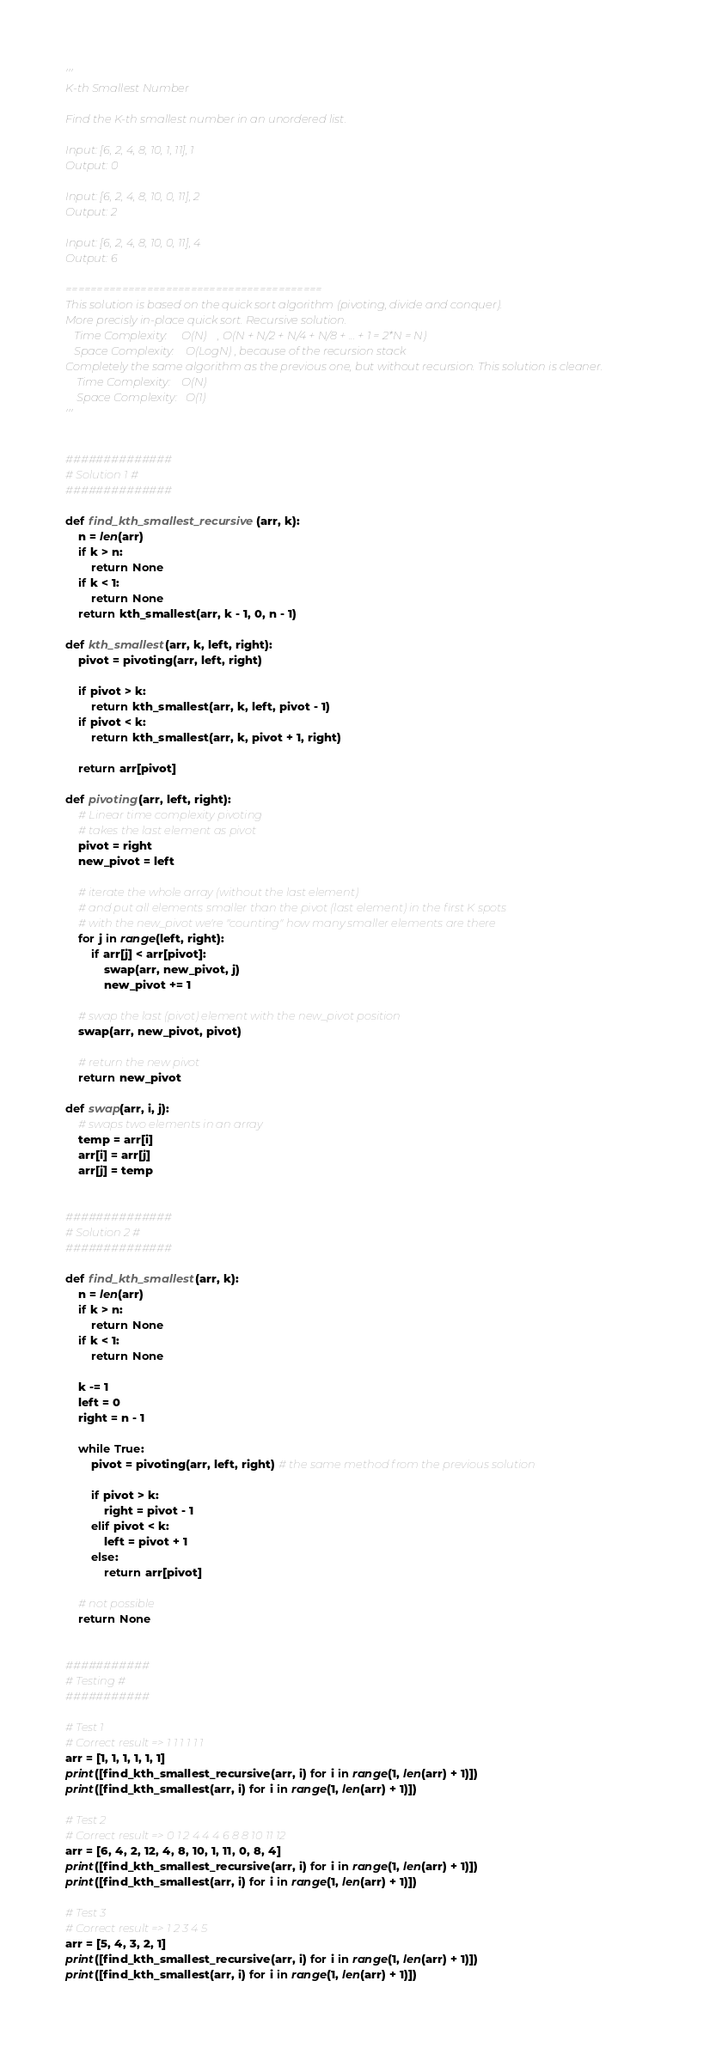Convert code to text. <code><loc_0><loc_0><loc_500><loc_500><_Python_>'''
K-th Smallest Number

Find the K-th smallest number in an unordered list.

Input: [6, 2, 4, 8, 10, 1, 11], 1
Output: 0

Input: [6, 2, 4, 8, 10, 0, 11], 2
Output: 2

Input: [6, 2, 4, 8, 10, 0, 11], 4
Output: 6

=========================================
This solution is based on the quick sort algorithm (pivoting, divide and conquer).
More precisly in-place quick sort. Recursive solution.
   Time Complexity:     O(N)    , O(N + N/2 + N/4 + N/8 + ... + 1 = 2*N = N)
   Space Complexity:    O(LogN) , because of the recursion stack
Completely the same algorithm as the previous one, but without recursion. This solution is cleaner.
    Time Complexity:    O(N)
    Space Complexity:   O(1)
'''


##############
# Solution 1 #
##############

def find_kth_smallest_recursive(arr, k):
    n = len(arr)
    if k > n:
        return None
    if k < 1:
        return None
    return kth_smallest(arr, k - 1, 0, n - 1)

def kth_smallest(arr, k, left, right):
    pivot = pivoting(arr, left, right)

    if pivot > k:
        return kth_smallest(arr, k, left, pivot - 1)
    if pivot < k:
        return kth_smallest(arr, k, pivot + 1, right)

    return arr[pivot]

def pivoting(arr, left, right):
    # Linear time complexity pivoting
    # takes the last element as pivot
    pivot = right
    new_pivot = left

    # iterate the whole array (without the last element)
    # and put all elements smaller than the pivot (last element) in the first K spots
    # with the new_pivot we're "counting" how many smaller elements are there
    for j in range(left, right):
        if arr[j] < arr[pivot]:
            swap(arr, new_pivot, j)
            new_pivot += 1

    # swap the last (pivot) element with the new_pivot position
    swap(arr, new_pivot, pivot)

    # return the new pivot
    return new_pivot

def swap(arr, i, j):
    # swaps two elements in an array
    temp = arr[i]
    arr[i] = arr[j]
    arr[j] = temp


##############
# Solution 2 #
##############

def find_kth_smallest(arr, k):
    n = len(arr)
    if k > n:
        return None
    if k < 1:
        return None

    k -= 1
    left = 0
    right = n - 1

    while True:
        pivot = pivoting(arr, left, right) # the same method from the previous solution

        if pivot > k:
            right = pivot - 1
        elif pivot < k:
            left = pivot + 1
        else:
            return arr[pivot]

    # not possible
    return None


###########
# Testing #
###########

# Test 1
# Correct result => 1 1 1 1 1 1
arr = [1, 1, 1, 1, 1, 1]
print([find_kth_smallest_recursive(arr, i) for i in range(1, len(arr) + 1)])
print([find_kth_smallest(arr, i) for i in range(1, len(arr) + 1)])

# Test 2
# Correct result => 0 1 2 4 4 4 6 8 8 10 11 12
arr = [6, 4, 2, 12, 4, 8, 10, 1, 11, 0, 8, 4]
print([find_kth_smallest_recursive(arr, i) for i in range(1, len(arr) + 1)])
print([find_kth_smallest(arr, i) for i in range(1, len(arr) + 1)])

# Test 3
# Correct result => 1 2 3 4 5
arr = [5, 4, 3, 2, 1]
print([find_kth_smallest_recursive(arr, i) for i in range(1, len(arr) + 1)])
print([find_kth_smallest(arr, i) for i in range(1, len(arr) + 1)])</code> 